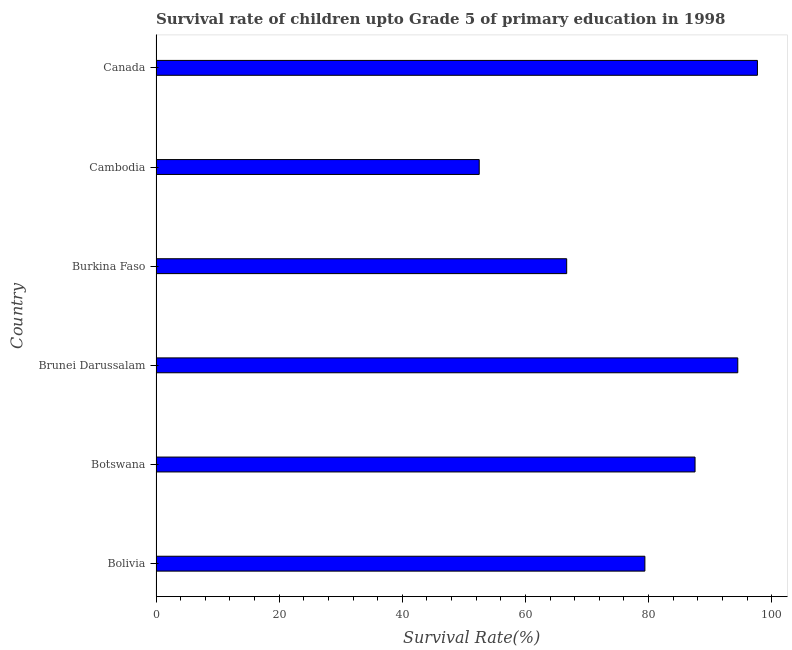Does the graph contain grids?
Offer a terse response. No. What is the title of the graph?
Offer a very short reply. Survival rate of children upto Grade 5 of primary education in 1998 . What is the label or title of the X-axis?
Your answer should be compact. Survival Rate(%). What is the survival rate in Burkina Faso?
Provide a short and direct response. 66.71. Across all countries, what is the maximum survival rate?
Provide a succinct answer. 97.69. Across all countries, what is the minimum survival rate?
Your answer should be very brief. 52.5. In which country was the survival rate minimum?
Your answer should be compact. Cambodia. What is the sum of the survival rate?
Provide a short and direct response. 478.35. What is the difference between the survival rate in Bolivia and Cambodia?
Offer a terse response. 26.91. What is the average survival rate per country?
Provide a short and direct response. 79.72. What is the median survival rate?
Offer a very short reply. 83.48. What is the ratio of the survival rate in Bolivia to that in Canada?
Your answer should be compact. 0.81. Is the survival rate in Burkina Faso less than that in Canada?
Keep it short and to the point. Yes. Is the difference between the survival rate in Brunei Darussalam and Cambodia greater than the difference between any two countries?
Provide a succinct answer. No. What is the difference between the highest and the second highest survival rate?
Offer a terse response. 3.19. What is the difference between the highest and the lowest survival rate?
Your answer should be compact. 45.19. How many bars are there?
Your answer should be compact. 6. How many countries are there in the graph?
Give a very brief answer. 6. What is the Survival Rate(%) in Bolivia?
Provide a short and direct response. 79.41. What is the Survival Rate(%) of Botswana?
Ensure brevity in your answer.  87.56. What is the Survival Rate(%) of Brunei Darussalam?
Your answer should be very brief. 94.5. What is the Survival Rate(%) of Burkina Faso?
Your answer should be compact. 66.71. What is the Survival Rate(%) of Cambodia?
Provide a succinct answer. 52.5. What is the Survival Rate(%) of Canada?
Your answer should be very brief. 97.69. What is the difference between the Survival Rate(%) in Bolivia and Botswana?
Ensure brevity in your answer.  -8.15. What is the difference between the Survival Rate(%) in Bolivia and Brunei Darussalam?
Provide a succinct answer. -15.09. What is the difference between the Survival Rate(%) in Bolivia and Burkina Faso?
Offer a terse response. 12.7. What is the difference between the Survival Rate(%) in Bolivia and Cambodia?
Ensure brevity in your answer.  26.91. What is the difference between the Survival Rate(%) in Bolivia and Canada?
Offer a terse response. -18.28. What is the difference between the Survival Rate(%) in Botswana and Brunei Darussalam?
Your answer should be very brief. -6.94. What is the difference between the Survival Rate(%) in Botswana and Burkina Faso?
Offer a terse response. 20.85. What is the difference between the Survival Rate(%) in Botswana and Cambodia?
Provide a succinct answer. 35.06. What is the difference between the Survival Rate(%) in Botswana and Canada?
Keep it short and to the point. -10.13. What is the difference between the Survival Rate(%) in Brunei Darussalam and Burkina Faso?
Give a very brief answer. 27.79. What is the difference between the Survival Rate(%) in Brunei Darussalam and Cambodia?
Your answer should be compact. 42. What is the difference between the Survival Rate(%) in Brunei Darussalam and Canada?
Ensure brevity in your answer.  -3.19. What is the difference between the Survival Rate(%) in Burkina Faso and Cambodia?
Provide a succinct answer. 14.21. What is the difference between the Survival Rate(%) in Burkina Faso and Canada?
Provide a succinct answer. -30.98. What is the difference between the Survival Rate(%) in Cambodia and Canada?
Keep it short and to the point. -45.19. What is the ratio of the Survival Rate(%) in Bolivia to that in Botswana?
Give a very brief answer. 0.91. What is the ratio of the Survival Rate(%) in Bolivia to that in Brunei Darussalam?
Your response must be concise. 0.84. What is the ratio of the Survival Rate(%) in Bolivia to that in Burkina Faso?
Offer a terse response. 1.19. What is the ratio of the Survival Rate(%) in Bolivia to that in Cambodia?
Provide a succinct answer. 1.51. What is the ratio of the Survival Rate(%) in Bolivia to that in Canada?
Make the answer very short. 0.81. What is the ratio of the Survival Rate(%) in Botswana to that in Brunei Darussalam?
Provide a succinct answer. 0.93. What is the ratio of the Survival Rate(%) in Botswana to that in Burkina Faso?
Your answer should be compact. 1.31. What is the ratio of the Survival Rate(%) in Botswana to that in Cambodia?
Provide a short and direct response. 1.67. What is the ratio of the Survival Rate(%) in Botswana to that in Canada?
Give a very brief answer. 0.9. What is the ratio of the Survival Rate(%) in Brunei Darussalam to that in Burkina Faso?
Make the answer very short. 1.42. What is the ratio of the Survival Rate(%) in Brunei Darussalam to that in Cambodia?
Your answer should be compact. 1.8. What is the ratio of the Survival Rate(%) in Burkina Faso to that in Cambodia?
Your answer should be compact. 1.27. What is the ratio of the Survival Rate(%) in Burkina Faso to that in Canada?
Your response must be concise. 0.68. What is the ratio of the Survival Rate(%) in Cambodia to that in Canada?
Offer a terse response. 0.54. 